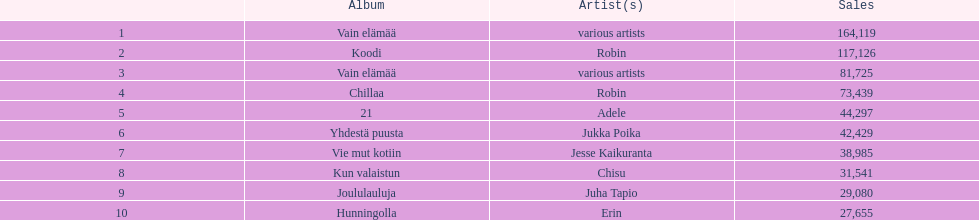Which album had the smallest number of sales? Hunningolla. 